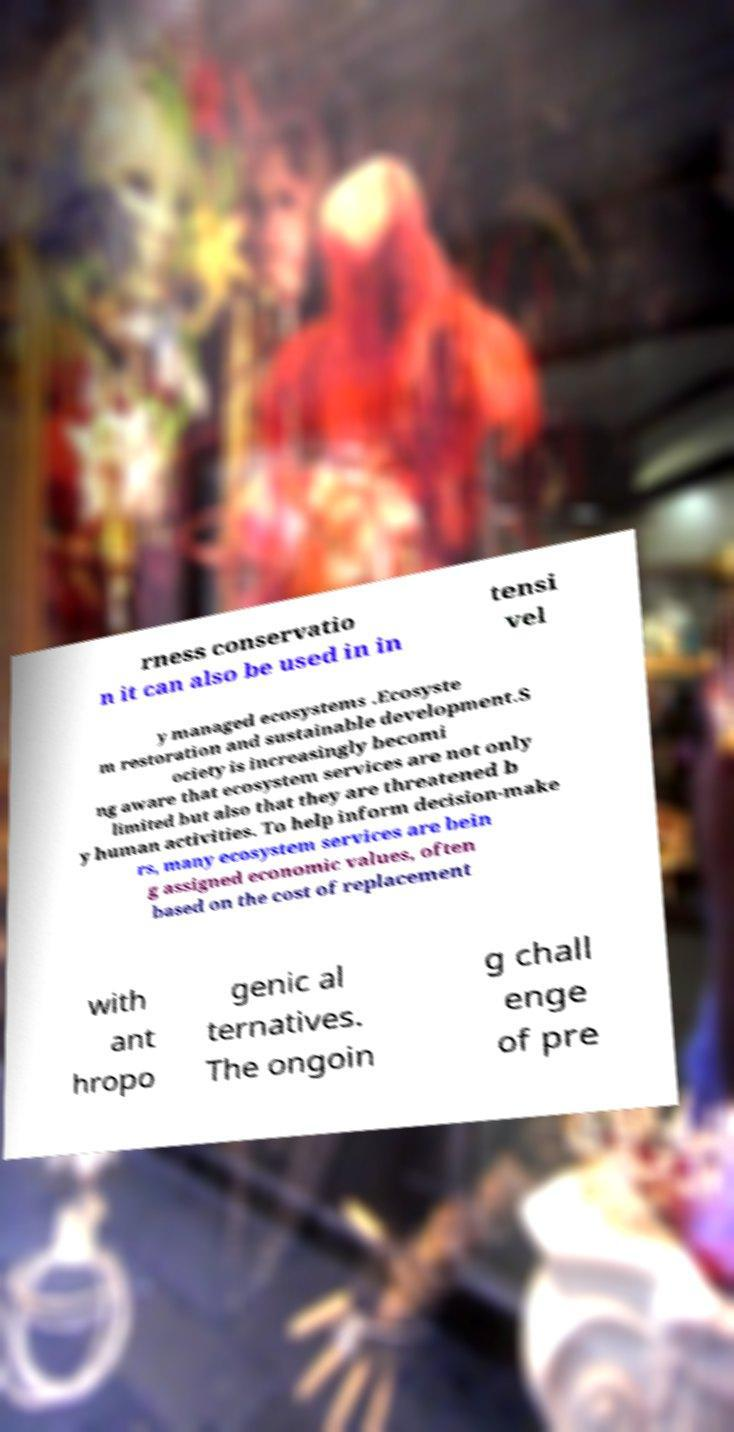There's text embedded in this image that I need extracted. Can you transcribe it verbatim? rness conservatio n it can also be used in in tensi vel y managed ecosystems .Ecosyste m restoration and sustainable development.S ociety is increasingly becomi ng aware that ecosystem services are not only limited but also that they are threatened b y human activities. To help inform decision-make rs, many ecosystem services are bein g assigned economic values, often based on the cost of replacement with ant hropo genic al ternatives. The ongoin g chall enge of pre 